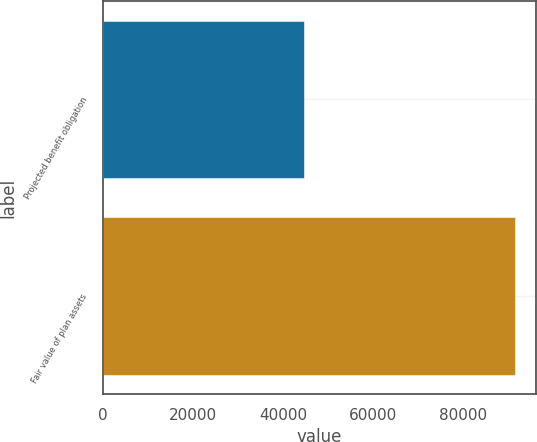Convert chart to OTSL. <chart><loc_0><loc_0><loc_500><loc_500><bar_chart><fcel>Projected benefit obligation<fcel>Fair value of plan assets<nl><fcel>44646<fcel>91610<nl></chart> 